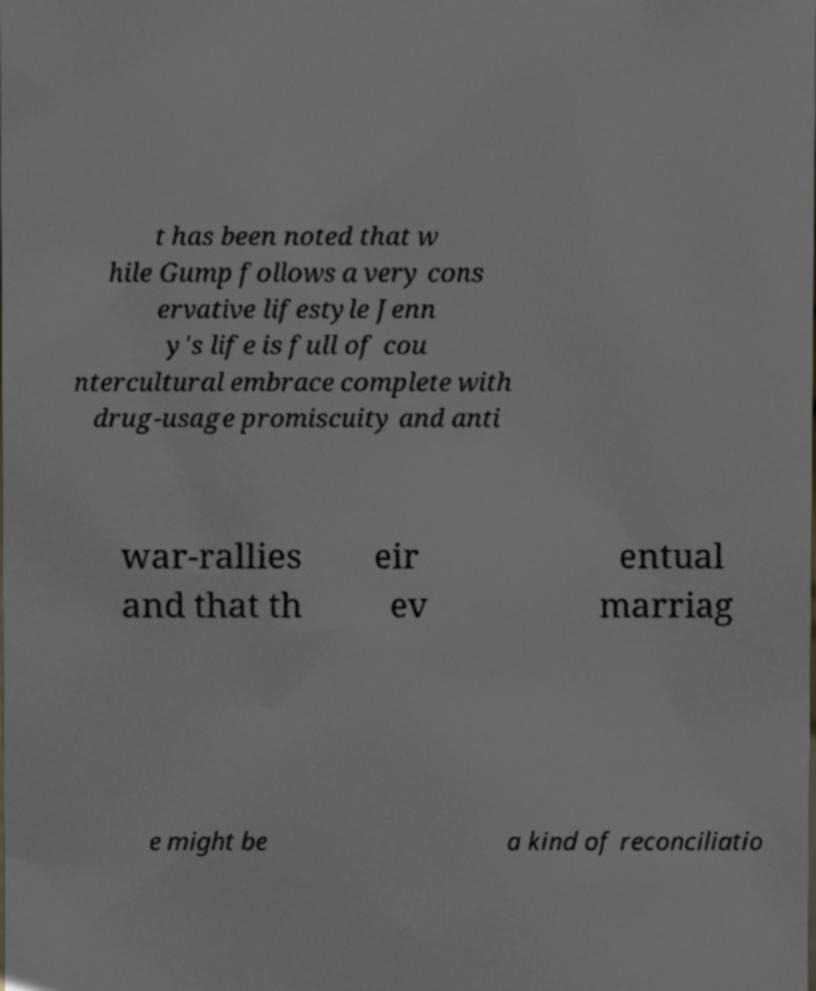Could you assist in decoding the text presented in this image and type it out clearly? t has been noted that w hile Gump follows a very cons ervative lifestyle Jenn y's life is full of cou ntercultural embrace complete with drug-usage promiscuity and anti war-rallies and that th eir ev entual marriag e might be a kind of reconciliatio 